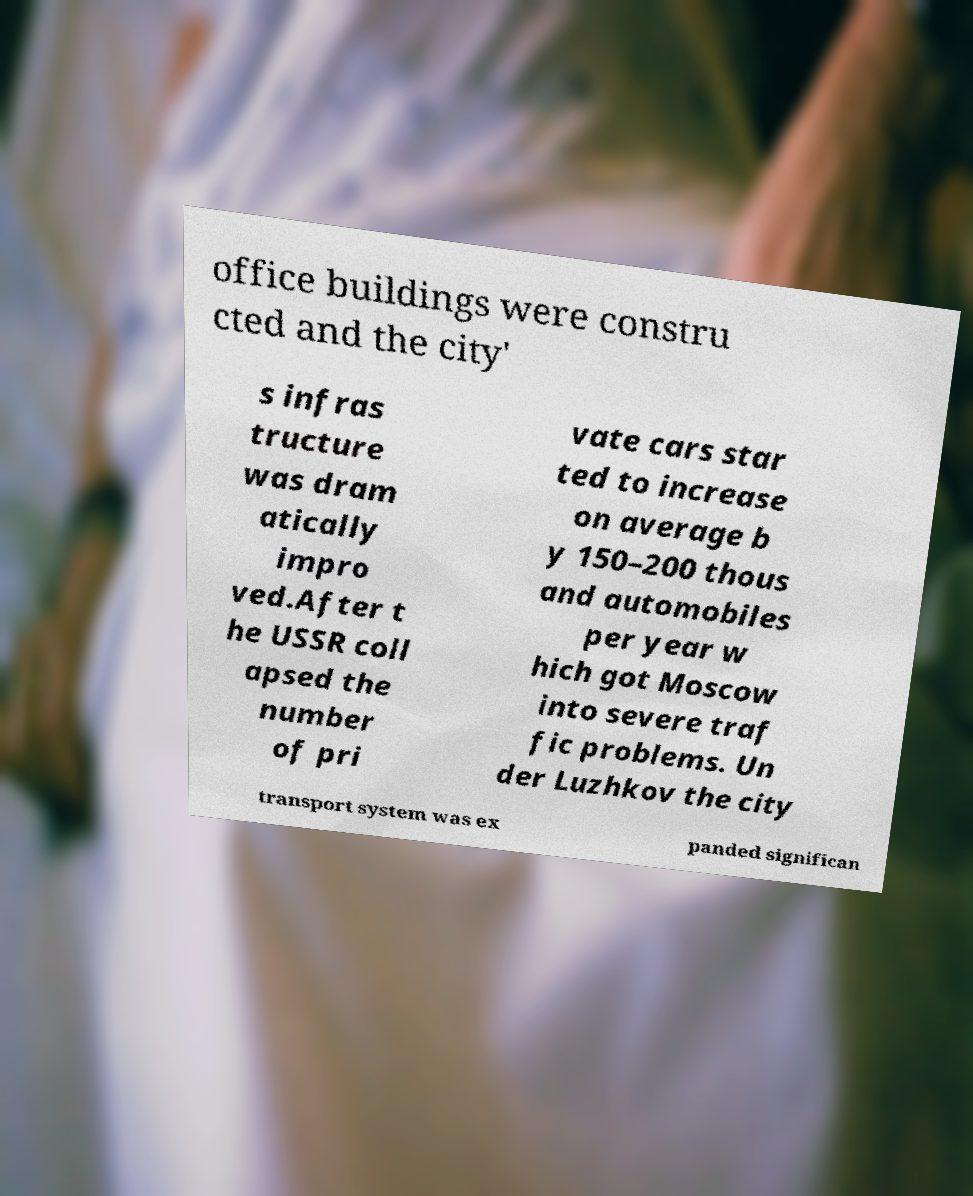Please read and relay the text visible in this image. What does it say? office buildings were constru cted and the city' s infras tructure was dram atically impro ved.After t he USSR coll apsed the number of pri vate cars star ted to increase on average b y 150–200 thous and automobiles per year w hich got Moscow into severe traf fic problems. Un der Luzhkov the city transport system was ex panded significan 